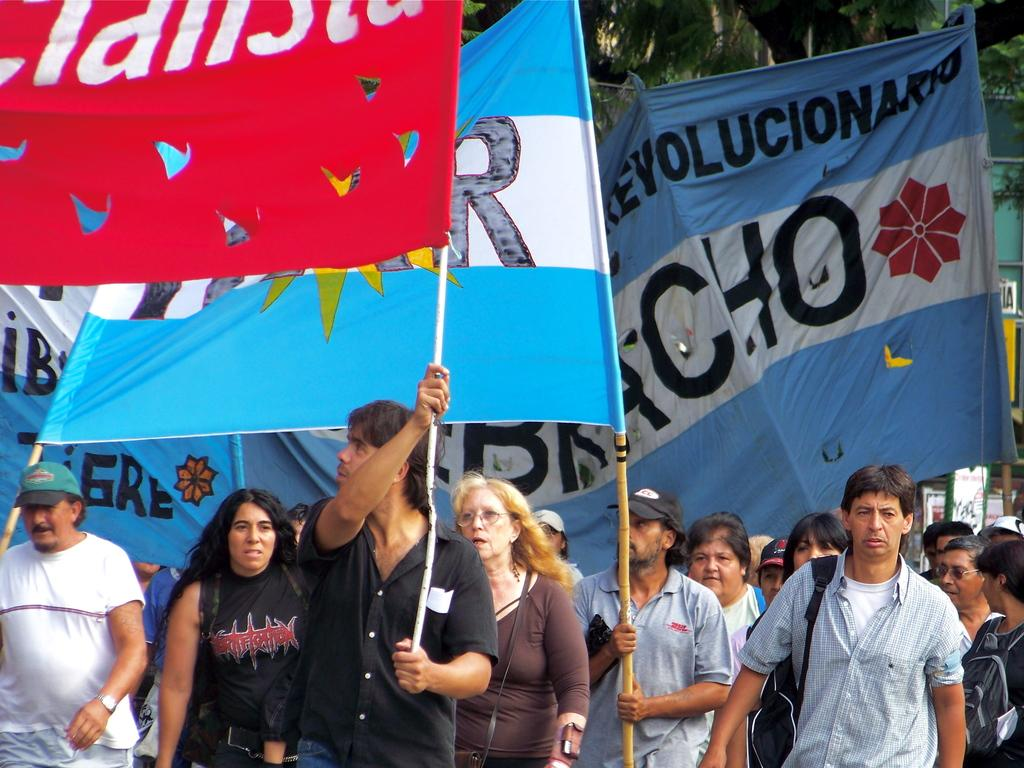<image>
Offer a succinct explanation of the picture presented. people marching holding flags and one man wearing a blue DHL shirt 